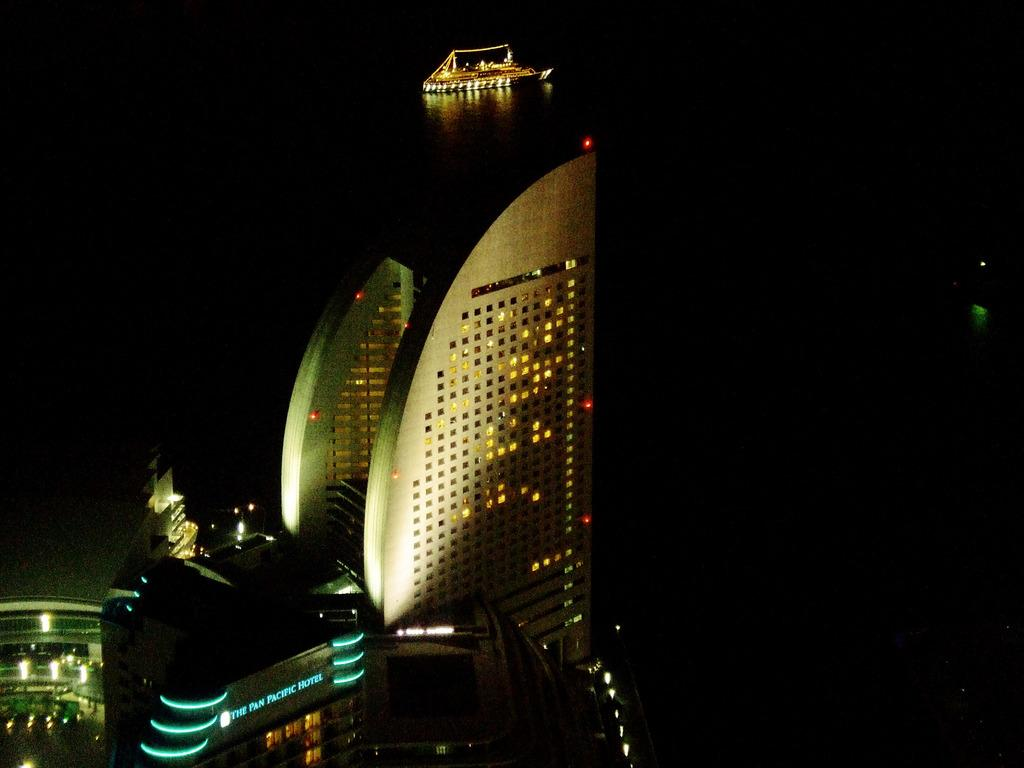<image>
Create a compact narrative representing the image presented. The pan pacific hotel lit up at night. 